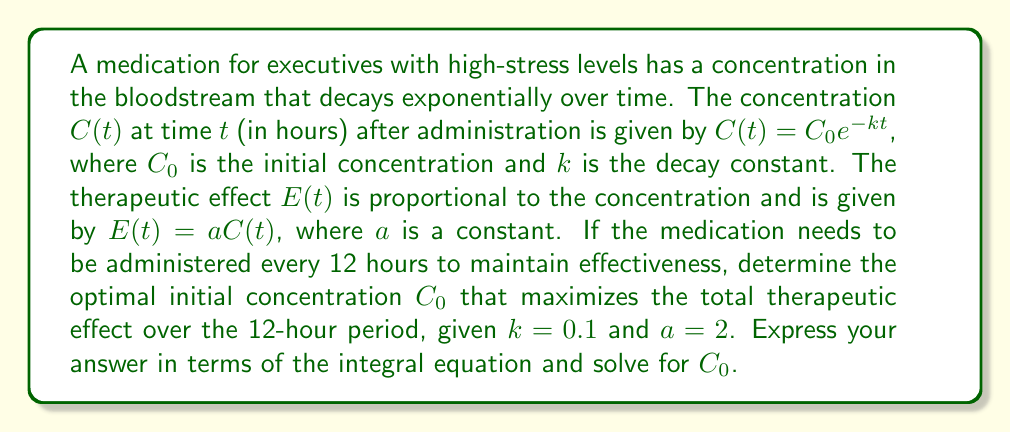Could you help me with this problem? To solve this problem, we'll follow these steps:

1) The total therapeutic effect over 12 hours is given by the integral of $E(t)$ from 0 to 12:

   $$\text{Total Effect} = \int_0^{12} E(t) dt = \int_0^{12} aC(t) dt = a \int_0^{12} C_0e^{-kt} dt$$

2) Substitute the given values $a = 2$ and $k = 0.1$:

   $$\text{Total Effect} = 2C_0 \int_0^{12} e^{-0.1t} dt$$

3) Solve the integral:

   $$\text{Total Effect} = 2C_0 \left[-10e^{-0.1t}\right]_0^{12}$$
   $$= 2C_0 \left[-10e^{-1.2} + 10\right]$$
   $$= 2C_0 \left[10(1 - e^{-1.2})\right]$$
   $$= 20C_0(1 - e^{-1.2})$$

4) To find the optimal $C_0$, we need to consider the constraints. In this case, we want to maximize the total effect while ensuring the concentration at the end of the 12-hour period is still therapeutic. Let's say we want the final concentration to be at least 10% of the initial concentration.

5) This constraint can be expressed as:

   $$C(12) = C_0e^{-0.1 \cdot 12} \geq 0.1C_0$$

6) Solving this inequality:

   $$e^{-1.2} \geq 0.1$$
   $$e^{-1.2} \approx 0.301 > 0.1$$

   This constraint is automatically satisfied due to the given decay rate.

7) Since there's no upper limit on $C_0$ in our constraints, the optimal $C_0$ would theoretically be infinite to maximize the total effect. However, in practice, there would be an upper limit due to toxicity concerns.

8) Let's say the maximum safe initial concentration is 100 units. Then the optimal $C_0$ would be 100, and the maximum total therapeutic effect would be:

   $$\text{Max Total Effect} = 20 \cdot 100 \cdot (1 - e^{-1.2}) \approx 1940.42$$
Answer: $C_0 = 100$ (assuming a maximum safe concentration of 100 units) 